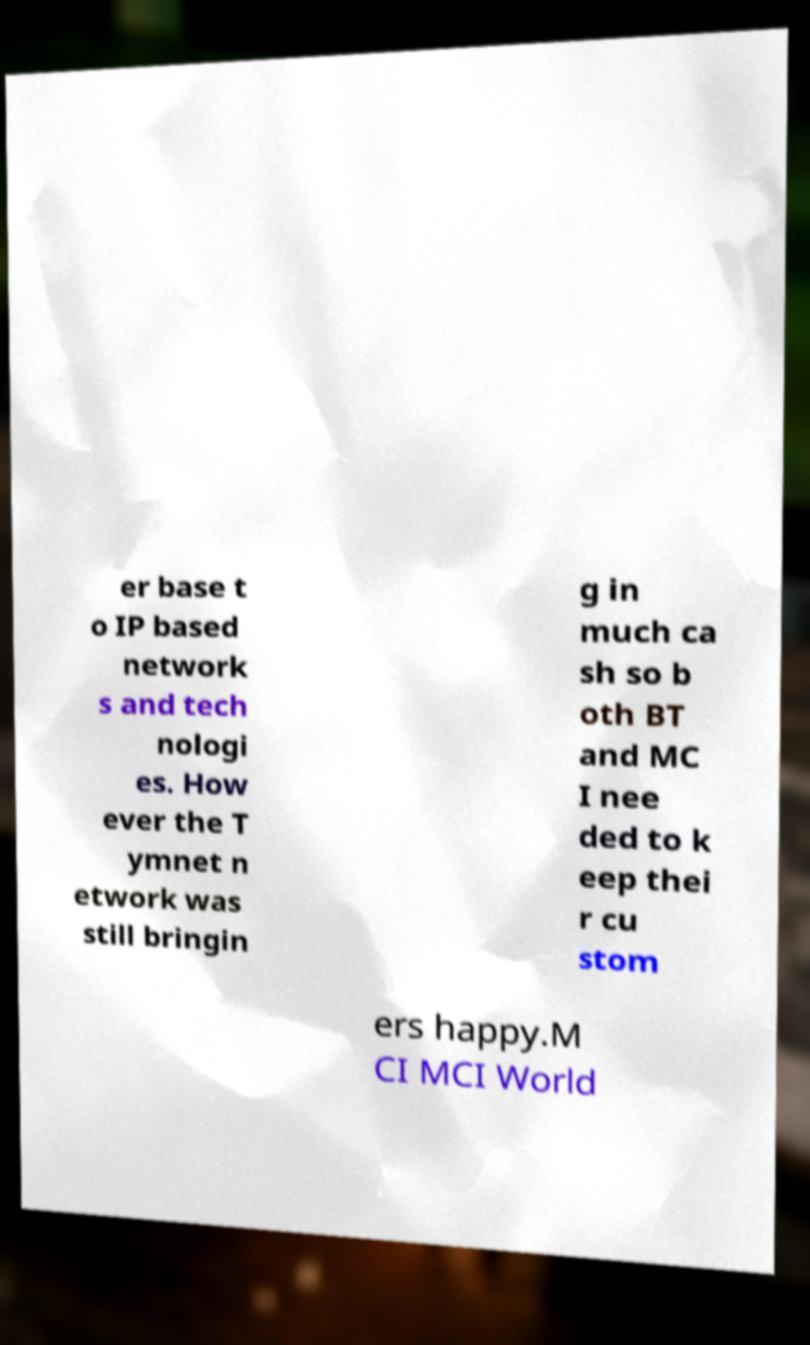Please read and relay the text visible in this image. What does it say? er base t o IP based network s and tech nologi es. How ever the T ymnet n etwork was still bringin g in much ca sh so b oth BT and MC I nee ded to k eep thei r cu stom ers happy.M CI MCI World 